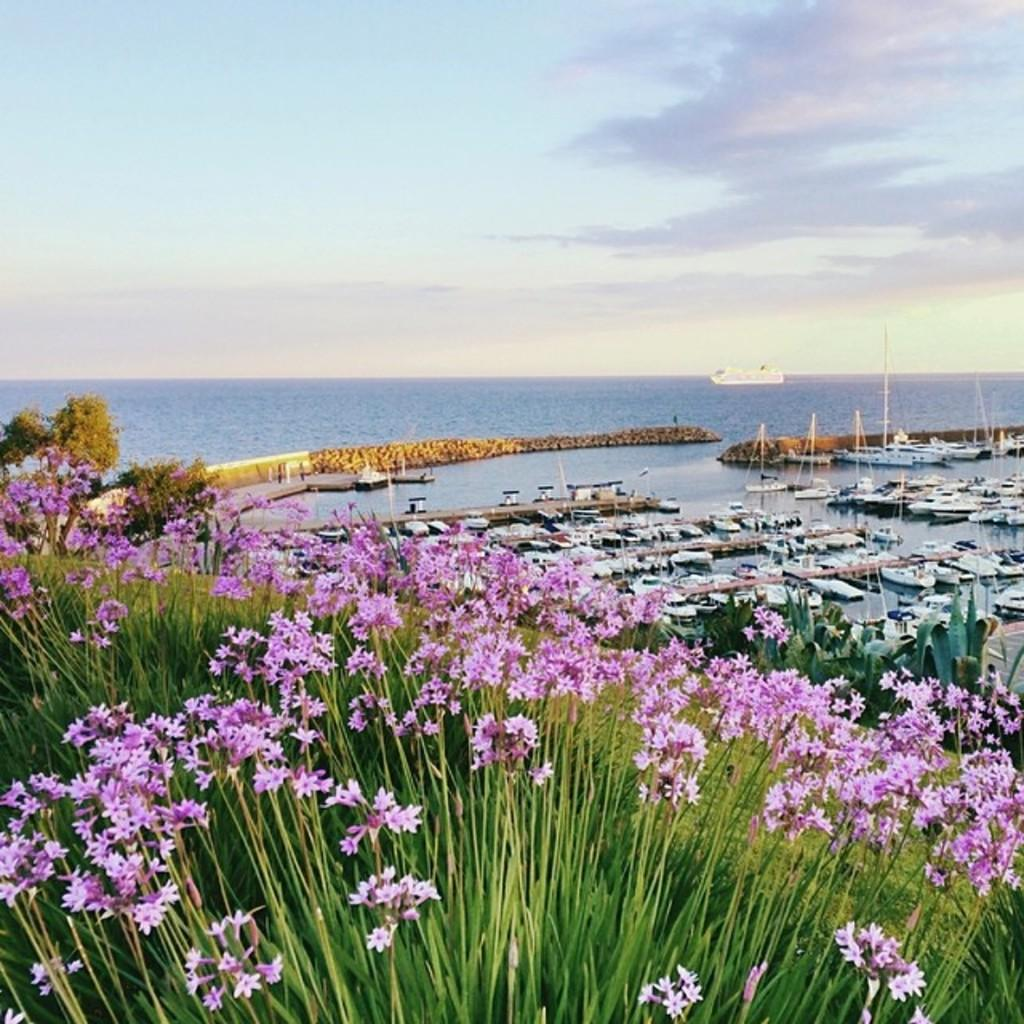What type of vegetation can be seen in the image? There are trees, plants, and flowers in the image. Where are the boats and ship located in the image? They are on the right side of the image. What is the boats and ship situated on? The boats and ship are on water. What is visible at the top of the image? The sky is visible at the top of the image. What effect does the knee have on the part of the image? There is no mention of a knee or any part in the image, so it is not possible to determine any effect. 